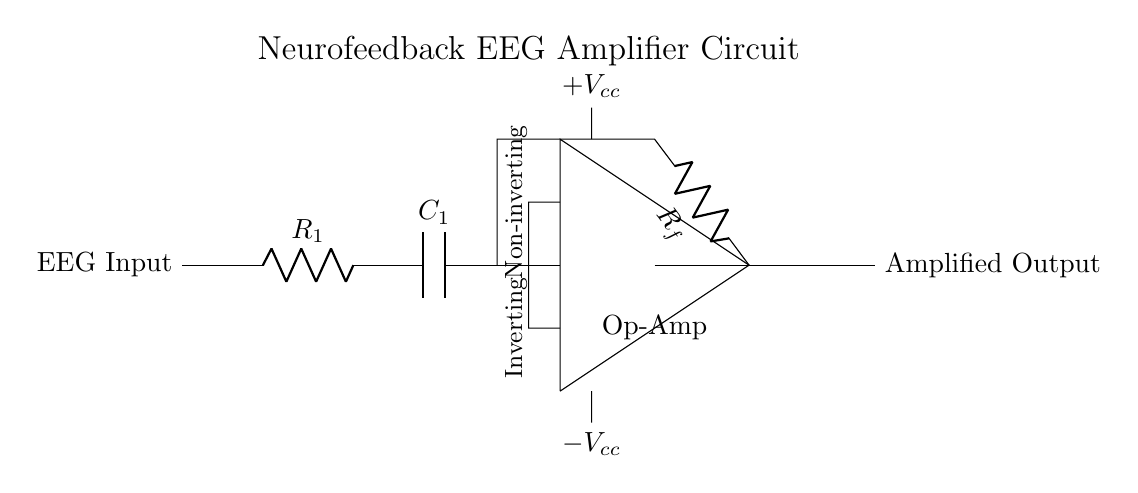What is the type of amplifier used in this circuit? The circuit uses an operational amplifier, which is indicated by the label "Op-Amp" in the diagram.
Answer: Operational amplifier What does R1 represent in the circuit? R1 is labeled as a resistor in the circuit, indicating it functions as part of the input stage to limit current or set gain.
Answer: Resistor What is the function of C1 in this circuit? C1 is a capacitor, and capacitors are often used in circuits to filter signals or couple AC signals while blocking DC.
Answer: Capacitor What are the voltage supply levels for this circuit? The circuit provides a positive voltage supply of 5V and a negative voltage supply of -5V as noted by the labels near the power connections.
Answer: Plus five volts and minus five volts What type of feedback does this operational amplifier use? The operational amplifier in this circuit uses positive feedback, indicated by the connection from the output back to the non-inverting input.
Answer: Positive feedback What does the term 'non-inverting' indicate in the context of this op-amp? 'Non-inverting' indicates that the input signal is applied to the non-inverting terminal and the output phase is the same as the input phase, leading to amplified output in phase with input.
Answer: Same phase How does the value of Rf affect the gain of this amplifier? The resistance value of Rf in the feedback network influences the gain of the amplifier; higher Rf values lead to higher gain according to the formula for gain in an inverting amplifier configuration.
Answer: Higher gain 